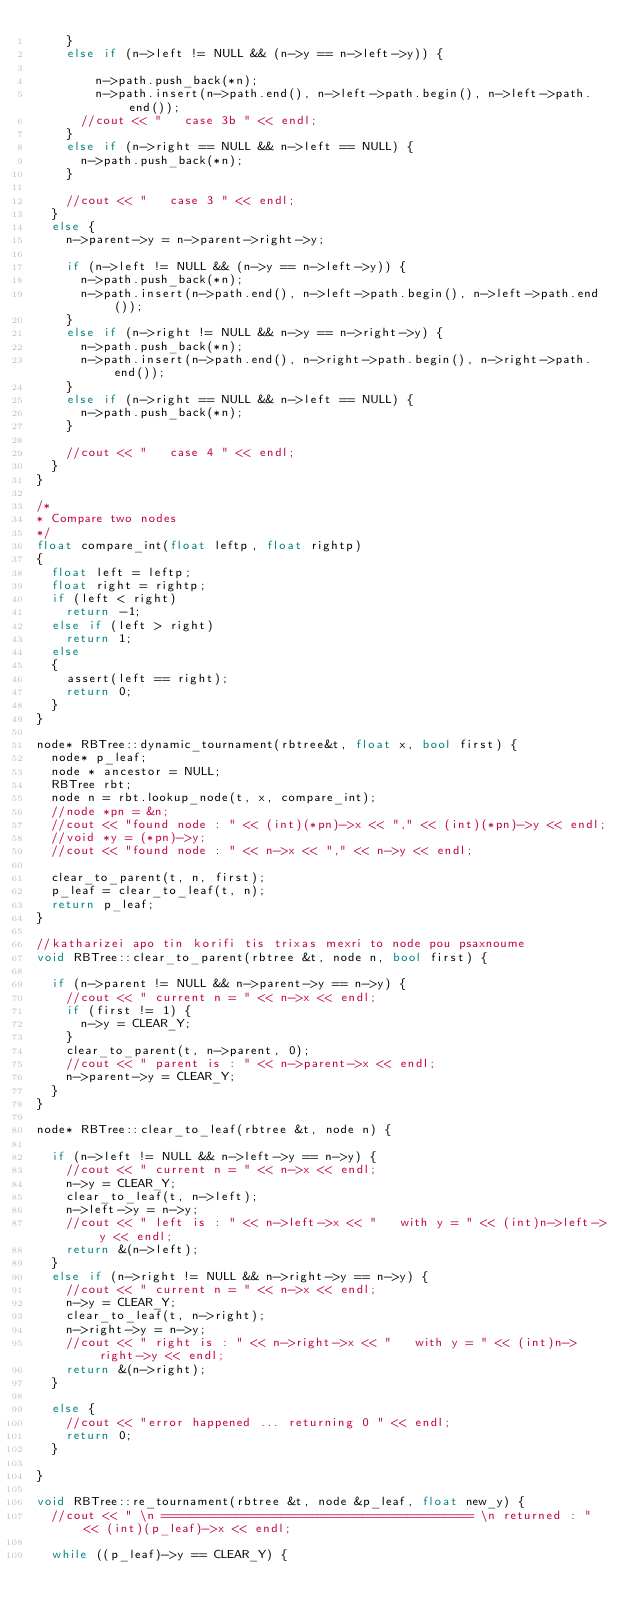<code> <loc_0><loc_0><loc_500><loc_500><_C++_>		}
		else if (n->left != NULL && (n->y == n->left->y)) {
				
				n->path.push_back(*n);
				n->path.insert(n->path.end(), n->left->path.begin(), n->left->path.end());
			//cout << "   case 3b " << endl;
		}
		else if (n->right == NULL && n->left == NULL) {
			n->path.push_back(*n);
		}

		//cout << "   case 3 " << endl;
	}
	else {
		n->parent->y = n->parent->right->y;

		if (n->left != NULL && (n->y == n->left->y)) {
			n->path.push_back(*n);
			n->path.insert(n->path.end(), n->left->path.begin(), n->left->path.end());
		}
		else if (n->right != NULL && n->y == n->right->y) {
			n->path.push_back(*n);
			n->path.insert(n->path.end(), n->right->path.begin(), n->right->path.end());
		}
		else if (n->right == NULL && n->left == NULL) {
			n->path.push_back(*n);
		}

		//cout << "   case 4 " << endl;
	}
}

/*
* Compare two nodes
*/
float compare_int(float leftp, float rightp)
{
	float left = leftp;
	float right = rightp;
	if (left < right)
		return -1;
	else if (left > right)
		return 1;
	else
	{
		assert(left == right);
		return 0;
	}
}

node* RBTree::dynamic_tournament(rbtree&t, float x, bool first) {
	node* p_leaf;
	node * ancestor = NULL;
	RBTree rbt;
	node n = rbt.lookup_node(t, x, compare_int);
	//node *pn = &n;
	//cout << "found node : " << (int)(*pn)->x << "," << (int)(*pn)->y << endl;
	//void *y = (*pn)->y;
	//cout << "found node : " << n->x << "," << n->y << endl;

	clear_to_parent(t, n, first);
	p_leaf = clear_to_leaf(t, n);
	return p_leaf;
}

//katharizei apo tin korifi tis trixas mexri to node pou psaxnoume
void RBTree::clear_to_parent(rbtree &t, node n, bool first) {

	if (n->parent != NULL && n->parent->y == n->y) {
		//cout << " current n = " << n->x << endl;
		if (first != 1) {
			n->y = CLEAR_Y;
		}
		clear_to_parent(t, n->parent, 0);
		//cout << " parent is : " << n->parent->x << endl;
		n->parent->y = CLEAR_Y;
	}
}

node* RBTree::clear_to_leaf(rbtree &t, node n) {

	if (n->left != NULL && n->left->y == n->y) {
		//cout << " current n = " << n->x << endl;
		n->y = CLEAR_Y;
		clear_to_leaf(t, n->left);
		n->left->y = n->y;
		//cout << " left is : " << n->left->x << "   with y = " << (int)n->left->y << endl;
		return &(n->left);
	}
	else if (n->right != NULL && n->right->y == n->y) {
		//cout << " current n = " << n->x << endl;
		n->y = CLEAR_Y;
		clear_to_leaf(t, n->right);
		n->right->y = n->y;
		//cout << " right is : " << n->right->x << "   with y = " << (int)n->right->y << endl;
		return &(n->right);
	}

	else {
		//cout << "error happened ... returning 0 " << endl;
		return 0;
	}

}

void RBTree::re_tournament(rbtree &t, node &p_leaf, float new_y) {
	//cout << " \n ========================================== \n returned : " << (int)(p_leaf)->x << endl;

	while ((p_leaf)->y == CLEAR_Y) {
</code> 